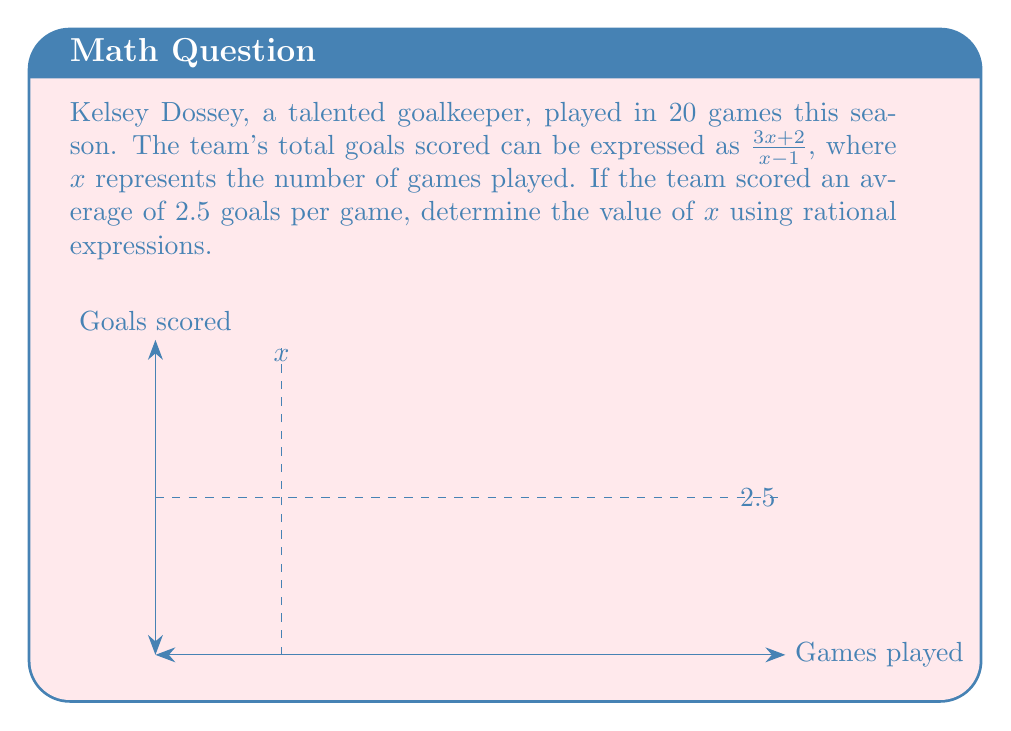Give your solution to this math problem. Let's approach this step-by-step:

1) We know that the average goals per game is 2.5. This can be expressed as:

   $\frac{\text{Total goals}}{\text{Number of games}} = 2.5$

2) We're given that the total goals is $\frac{3x+2}{x-1}$ and the number of games is $x$. So we can write:

   $\frac{\frac{3x+2}{x-1}}{x} = 2.5$

3) To solve this, let's first multiply both sides by $x$:

   $\frac{3x+2}{x-1} = 2.5x$

4) Now, let's multiply both sides by $(x-1)$:

   $3x+2 = 2.5x(x-1)$

5) Expand the right side:

   $3x+2 = 2.5x^2 - 2.5x$

6) Rearrange the terms:

   $2.5x^2 - 5.5x - 2 = 0$

7) This is a quadratic equation. We can solve it using the quadratic formula:

   $x = \frac{-b \pm \sqrt{b^2 - 4ac}}{2a}$

   Where $a=2.5$, $b=-5.5$, and $c=-2$

8) Plugging in these values:

   $x = \frac{5.5 \pm \sqrt{(-5.5)^2 - 4(2.5)(-2)}}{2(2.5)}$

9) Simplify:

   $x = \frac{5.5 \pm \sqrt{30.25 + 20}}{5} = \frac{5.5 \pm \sqrt{50.25}}{5}$

10) Simplify further:

    $x = \frac{5.5 \pm 7.09}{5}$

11) This gives us two solutions:

    $x = \frac{5.5 + 7.09}{5} = 2.518$ or $x = \frac{5.5 - 7.09}{5} = -0.318$

12) Since $x$ represents the number of games, it must be positive. Therefore, $x \approx 2.518$.

13) However, we're told that Kelsey played in 20 games, so $x$ must equal 20.
Answer: $x = 20$ 